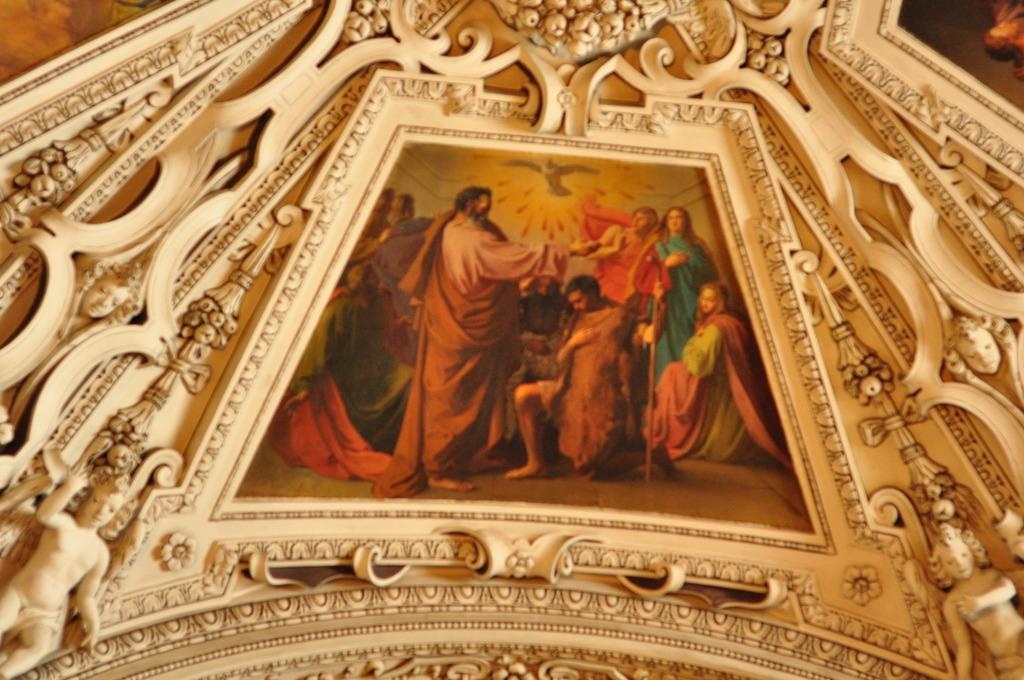How would you summarize this image in a sentence or two? As we can see in the image there is a photo frame. In the photo frame there are few people and there are sculptures. 